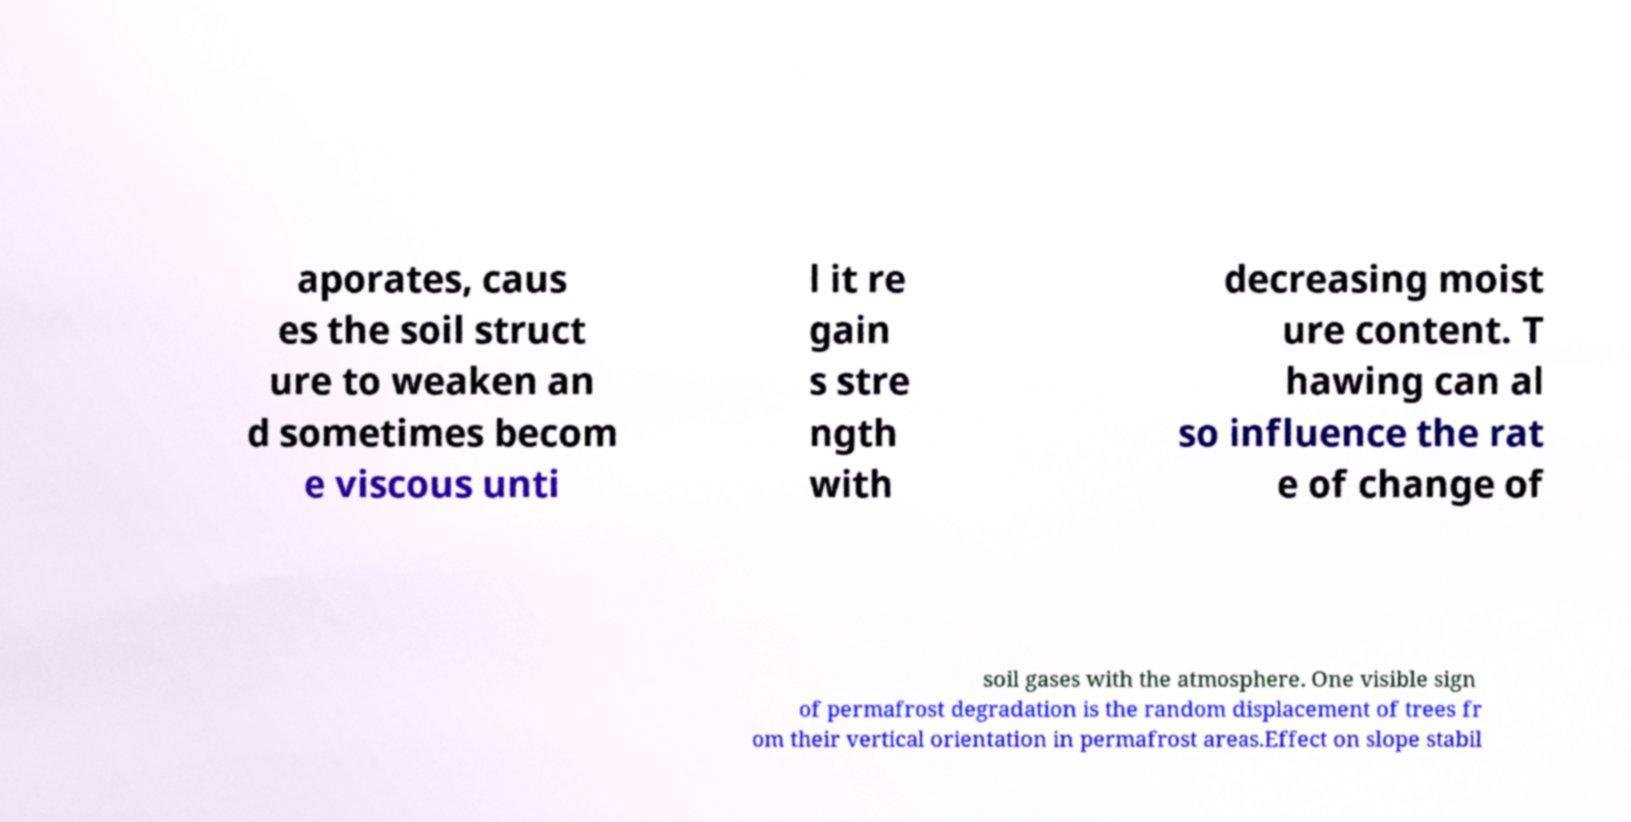For documentation purposes, I need the text within this image transcribed. Could you provide that? aporates, caus es the soil struct ure to weaken an d sometimes becom e viscous unti l it re gain s stre ngth with decreasing moist ure content. T hawing can al so influence the rat e of change of soil gases with the atmosphere. One visible sign of permafrost degradation is the random displacement of trees fr om their vertical orientation in permafrost areas.Effect on slope stabil 